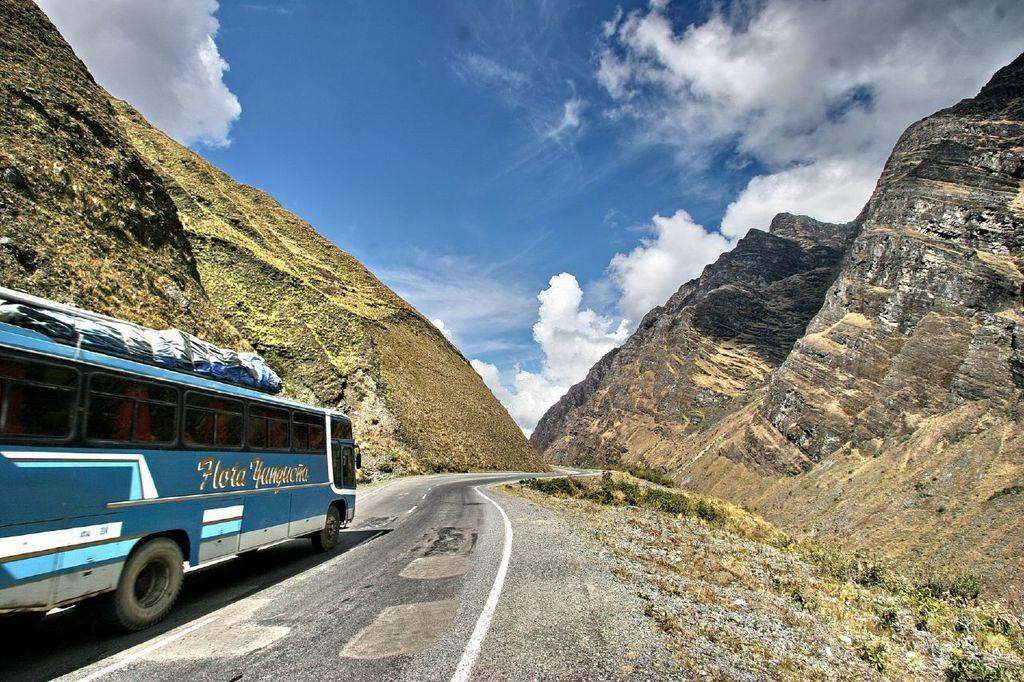What is located on the left side of the image? There is a bus on the left side of the image. What is the bus doing in the image? The bus is on a road in the image. What can be seen on the right side of the image? There are plants and grass on the ground on the right side of the image. What is visible in the background of the image? There are mountains and clouds in the sky in the background of the image. Can you tell me how many points the woman is scoring in the image? There is no woman or any indication of scoring points in the image; it features a bus on a road with plants, grass, mountains, and clouds in the background. 